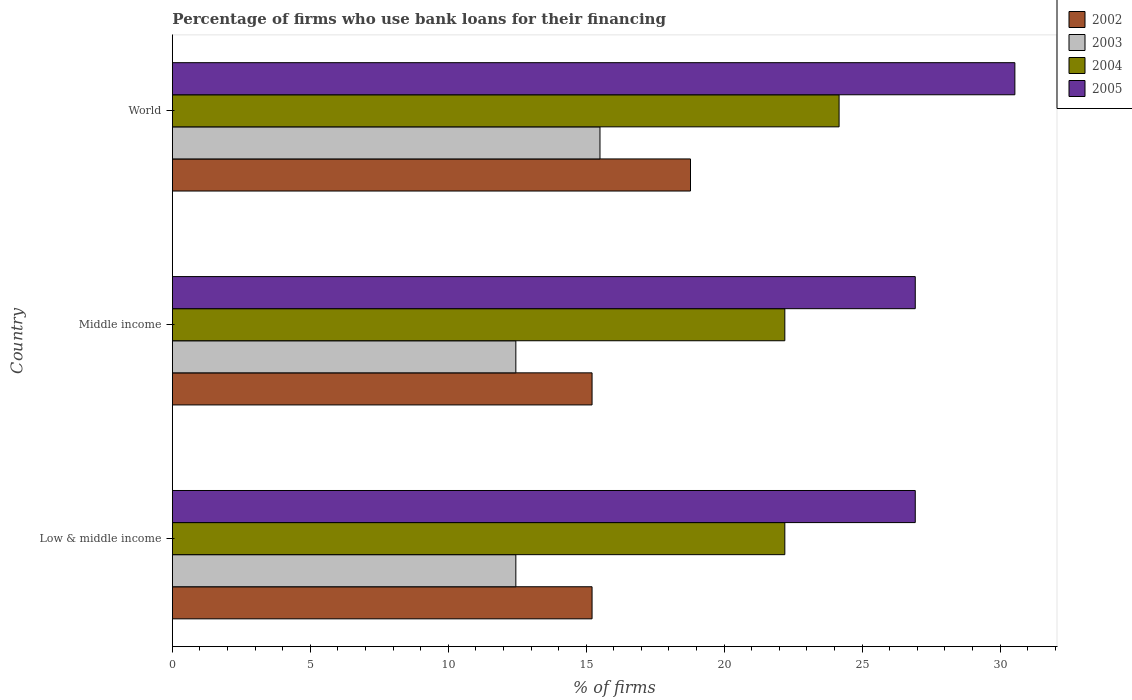How many groups of bars are there?
Your answer should be compact. 3. Are the number of bars per tick equal to the number of legend labels?
Offer a very short reply. Yes. How many bars are there on the 2nd tick from the top?
Offer a very short reply. 4. How many bars are there on the 3rd tick from the bottom?
Your answer should be compact. 4. What is the percentage of firms who use bank loans for their financing in 2003 in Low & middle income?
Your response must be concise. 12.45. Across all countries, what is the minimum percentage of firms who use bank loans for their financing in 2005?
Offer a very short reply. 26.93. What is the total percentage of firms who use bank loans for their financing in 2003 in the graph?
Offer a very short reply. 40.4. What is the difference between the percentage of firms who use bank loans for their financing in 2005 in Low & middle income and that in Middle income?
Your response must be concise. 0. What is the difference between the percentage of firms who use bank loans for their financing in 2002 in World and the percentage of firms who use bank loans for their financing in 2004 in Low & middle income?
Your answer should be very brief. -3.42. What is the average percentage of firms who use bank loans for their financing in 2002 per country?
Ensure brevity in your answer.  16.4. What is the difference between the percentage of firms who use bank loans for their financing in 2003 and percentage of firms who use bank loans for their financing in 2004 in World?
Provide a succinct answer. -8.67. In how many countries, is the percentage of firms who use bank loans for their financing in 2004 greater than 15 %?
Offer a very short reply. 3. Is the percentage of firms who use bank loans for their financing in 2003 in Low & middle income less than that in World?
Your response must be concise. Yes. What is the difference between the highest and the second highest percentage of firms who use bank loans for their financing in 2005?
Your response must be concise. 3.61. What is the difference between the highest and the lowest percentage of firms who use bank loans for their financing in 2003?
Give a very brief answer. 3.05. In how many countries, is the percentage of firms who use bank loans for their financing in 2003 greater than the average percentage of firms who use bank loans for their financing in 2003 taken over all countries?
Provide a short and direct response. 1. Is the sum of the percentage of firms who use bank loans for their financing in 2002 in Middle income and World greater than the maximum percentage of firms who use bank loans for their financing in 2005 across all countries?
Your response must be concise. Yes. Is it the case that in every country, the sum of the percentage of firms who use bank loans for their financing in 2004 and percentage of firms who use bank loans for their financing in 2005 is greater than the sum of percentage of firms who use bank loans for their financing in 2002 and percentage of firms who use bank loans for their financing in 2003?
Offer a terse response. Yes. What does the 1st bar from the bottom in Low & middle income represents?
Provide a succinct answer. 2002. Is it the case that in every country, the sum of the percentage of firms who use bank loans for their financing in 2002 and percentage of firms who use bank loans for their financing in 2004 is greater than the percentage of firms who use bank loans for their financing in 2003?
Offer a very short reply. Yes. How many bars are there?
Keep it short and to the point. 12. Are all the bars in the graph horizontal?
Provide a short and direct response. Yes. What is the difference between two consecutive major ticks on the X-axis?
Keep it short and to the point. 5. Are the values on the major ticks of X-axis written in scientific E-notation?
Ensure brevity in your answer.  No. Does the graph contain any zero values?
Your answer should be compact. No. Where does the legend appear in the graph?
Ensure brevity in your answer.  Top right. How many legend labels are there?
Provide a short and direct response. 4. What is the title of the graph?
Your answer should be very brief. Percentage of firms who use bank loans for their financing. What is the label or title of the X-axis?
Provide a succinct answer. % of firms. What is the % of firms of 2002 in Low & middle income?
Give a very brief answer. 15.21. What is the % of firms of 2003 in Low & middle income?
Ensure brevity in your answer.  12.45. What is the % of firms in 2004 in Low & middle income?
Ensure brevity in your answer.  22.2. What is the % of firms in 2005 in Low & middle income?
Provide a succinct answer. 26.93. What is the % of firms of 2002 in Middle income?
Provide a short and direct response. 15.21. What is the % of firms in 2003 in Middle income?
Provide a succinct answer. 12.45. What is the % of firms in 2004 in Middle income?
Make the answer very short. 22.2. What is the % of firms of 2005 in Middle income?
Ensure brevity in your answer.  26.93. What is the % of firms of 2002 in World?
Offer a very short reply. 18.78. What is the % of firms in 2004 in World?
Your response must be concise. 24.17. What is the % of firms in 2005 in World?
Offer a terse response. 30.54. Across all countries, what is the maximum % of firms of 2002?
Offer a terse response. 18.78. Across all countries, what is the maximum % of firms of 2004?
Ensure brevity in your answer.  24.17. Across all countries, what is the maximum % of firms in 2005?
Offer a very short reply. 30.54. Across all countries, what is the minimum % of firms of 2002?
Provide a short and direct response. 15.21. Across all countries, what is the minimum % of firms in 2003?
Your answer should be very brief. 12.45. Across all countries, what is the minimum % of firms of 2005?
Give a very brief answer. 26.93. What is the total % of firms of 2002 in the graph?
Give a very brief answer. 49.21. What is the total % of firms in 2003 in the graph?
Offer a very short reply. 40.4. What is the total % of firms of 2004 in the graph?
Your answer should be very brief. 68.57. What is the total % of firms of 2005 in the graph?
Provide a succinct answer. 84.39. What is the difference between the % of firms in 2002 in Low & middle income and that in Middle income?
Offer a terse response. 0. What is the difference between the % of firms in 2004 in Low & middle income and that in Middle income?
Ensure brevity in your answer.  0. What is the difference between the % of firms in 2005 in Low & middle income and that in Middle income?
Make the answer very short. 0. What is the difference between the % of firms of 2002 in Low & middle income and that in World?
Provide a short and direct response. -3.57. What is the difference between the % of firms in 2003 in Low & middle income and that in World?
Offer a terse response. -3.05. What is the difference between the % of firms in 2004 in Low & middle income and that in World?
Make the answer very short. -1.97. What is the difference between the % of firms of 2005 in Low & middle income and that in World?
Your response must be concise. -3.61. What is the difference between the % of firms in 2002 in Middle income and that in World?
Offer a terse response. -3.57. What is the difference between the % of firms in 2003 in Middle income and that in World?
Provide a succinct answer. -3.05. What is the difference between the % of firms of 2004 in Middle income and that in World?
Your answer should be very brief. -1.97. What is the difference between the % of firms of 2005 in Middle income and that in World?
Make the answer very short. -3.61. What is the difference between the % of firms in 2002 in Low & middle income and the % of firms in 2003 in Middle income?
Give a very brief answer. 2.76. What is the difference between the % of firms of 2002 in Low & middle income and the % of firms of 2004 in Middle income?
Offer a very short reply. -6.99. What is the difference between the % of firms in 2002 in Low & middle income and the % of firms in 2005 in Middle income?
Your answer should be compact. -11.72. What is the difference between the % of firms in 2003 in Low & middle income and the % of firms in 2004 in Middle income?
Give a very brief answer. -9.75. What is the difference between the % of firms of 2003 in Low & middle income and the % of firms of 2005 in Middle income?
Provide a succinct answer. -14.48. What is the difference between the % of firms of 2004 in Low & middle income and the % of firms of 2005 in Middle income?
Your answer should be compact. -4.73. What is the difference between the % of firms in 2002 in Low & middle income and the % of firms in 2003 in World?
Your answer should be very brief. -0.29. What is the difference between the % of firms of 2002 in Low & middle income and the % of firms of 2004 in World?
Make the answer very short. -8.95. What is the difference between the % of firms of 2002 in Low & middle income and the % of firms of 2005 in World?
Make the answer very short. -15.33. What is the difference between the % of firms in 2003 in Low & middle income and the % of firms in 2004 in World?
Your answer should be compact. -11.72. What is the difference between the % of firms of 2003 in Low & middle income and the % of firms of 2005 in World?
Offer a terse response. -18.09. What is the difference between the % of firms of 2004 in Low & middle income and the % of firms of 2005 in World?
Provide a succinct answer. -8.34. What is the difference between the % of firms in 2002 in Middle income and the % of firms in 2003 in World?
Provide a succinct answer. -0.29. What is the difference between the % of firms in 2002 in Middle income and the % of firms in 2004 in World?
Your answer should be very brief. -8.95. What is the difference between the % of firms in 2002 in Middle income and the % of firms in 2005 in World?
Offer a terse response. -15.33. What is the difference between the % of firms in 2003 in Middle income and the % of firms in 2004 in World?
Make the answer very short. -11.72. What is the difference between the % of firms of 2003 in Middle income and the % of firms of 2005 in World?
Your answer should be very brief. -18.09. What is the difference between the % of firms of 2004 in Middle income and the % of firms of 2005 in World?
Offer a terse response. -8.34. What is the average % of firms of 2002 per country?
Make the answer very short. 16.4. What is the average % of firms in 2003 per country?
Give a very brief answer. 13.47. What is the average % of firms of 2004 per country?
Give a very brief answer. 22.86. What is the average % of firms of 2005 per country?
Make the answer very short. 28.13. What is the difference between the % of firms in 2002 and % of firms in 2003 in Low & middle income?
Your answer should be very brief. 2.76. What is the difference between the % of firms of 2002 and % of firms of 2004 in Low & middle income?
Give a very brief answer. -6.99. What is the difference between the % of firms in 2002 and % of firms in 2005 in Low & middle income?
Your answer should be very brief. -11.72. What is the difference between the % of firms of 2003 and % of firms of 2004 in Low & middle income?
Provide a short and direct response. -9.75. What is the difference between the % of firms of 2003 and % of firms of 2005 in Low & middle income?
Offer a very short reply. -14.48. What is the difference between the % of firms in 2004 and % of firms in 2005 in Low & middle income?
Your answer should be very brief. -4.73. What is the difference between the % of firms in 2002 and % of firms in 2003 in Middle income?
Provide a short and direct response. 2.76. What is the difference between the % of firms of 2002 and % of firms of 2004 in Middle income?
Provide a succinct answer. -6.99. What is the difference between the % of firms in 2002 and % of firms in 2005 in Middle income?
Offer a terse response. -11.72. What is the difference between the % of firms of 2003 and % of firms of 2004 in Middle income?
Provide a short and direct response. -9.75. What is the difference between the % of firms of 2003 and % of firms of 2005 in Middle income?
Provide a short and direct response. -14.48. What is the difference between the % of firms in 2004 and % of firms in 2005 in Middle income?
Your response must be concise. -4.73. What is the difference between the % of firms in 2002 and % of firms in 2003 in World?
Make the answer very short. 3.28. What is the difference between the % of firms of 2002 and % of firms of 2004 in World?
Your answer should be very brief. -5.39. What is the difference between the % of firms of 2002 and % of firms of 2005 in World?
Your answer should be compact. -11.76. What is the difference between the % of firms of 2003 and % of firms of 2004 in World?
Keep it short and to the point. -8.67. What is the difference between the % of firms of 2003 and % of firms of 2005 in World?
Ensure brevity in your answer.  -15.04. What is the difference between the % of firms of 2004 and % of firms of 2005 in World?
Keep it short and to the point. -6.37. What is the ratio of the % of firms in 2004 in Low & middle income to that in Middle income?
Your response must be concise. 1. What is the ratio of the % of firms in 2002 in Low & middle income to that in World?
Your answer should be very brief. 0.81. What is the ratio of the % of firms of 2003 in Low & middle income to that in World?
Your answer should be very brief. 0.8. What is the ratio of the % of firms in 2004 in Low & middle income to that in World?
Make the answer very short. 0.92. What is the ratio of the % of firms of 2005 in Low & middle income to that in World?
Your response must be concise. 0.88. What is the ratio of the % of firms in 2002 in Middle income to that in World?
Make the answer very short. 0.81. What is the ratio of the % of firms in 2003 in Middle income to that in World?
Offer a terse response. 0.8. What is the ratio of the % of firms in 2004 in Middle income to that in World?
Your response must be concise. 0.92. What is the ratio of the % of firms in 2005 in Middle income to that in World?
Give a very brief answer. 0.88. What is the difference between the highest and the second highest % of firms in 2002?
Your answer should be compact. 3.57. What is the difference between the highest and the second highest % of firms in 2003?
Offer a very short reply. 3.05. What is the difference between the highest and the second highest % of firms of 2004?
Keep it short and to the point. 1.97. What is the difference between the highest and the second highest % of firms in 2005?
Offer a terse response. 3.61. What is the difference between the highest and the lowest % of firms in 2002?
Offer a very short reply. 3.57. What is the difference between the highest and the lowest % of firms in 2003?
Your answer should be very brief. 3.05. What is the difference between the highest and the lowest % of firms in 2004?
Provide a short and direct response. 1.97. What is the difference between the highest and the lowest % of firms of 2005?
Your answer should be very brief. 3.61. 